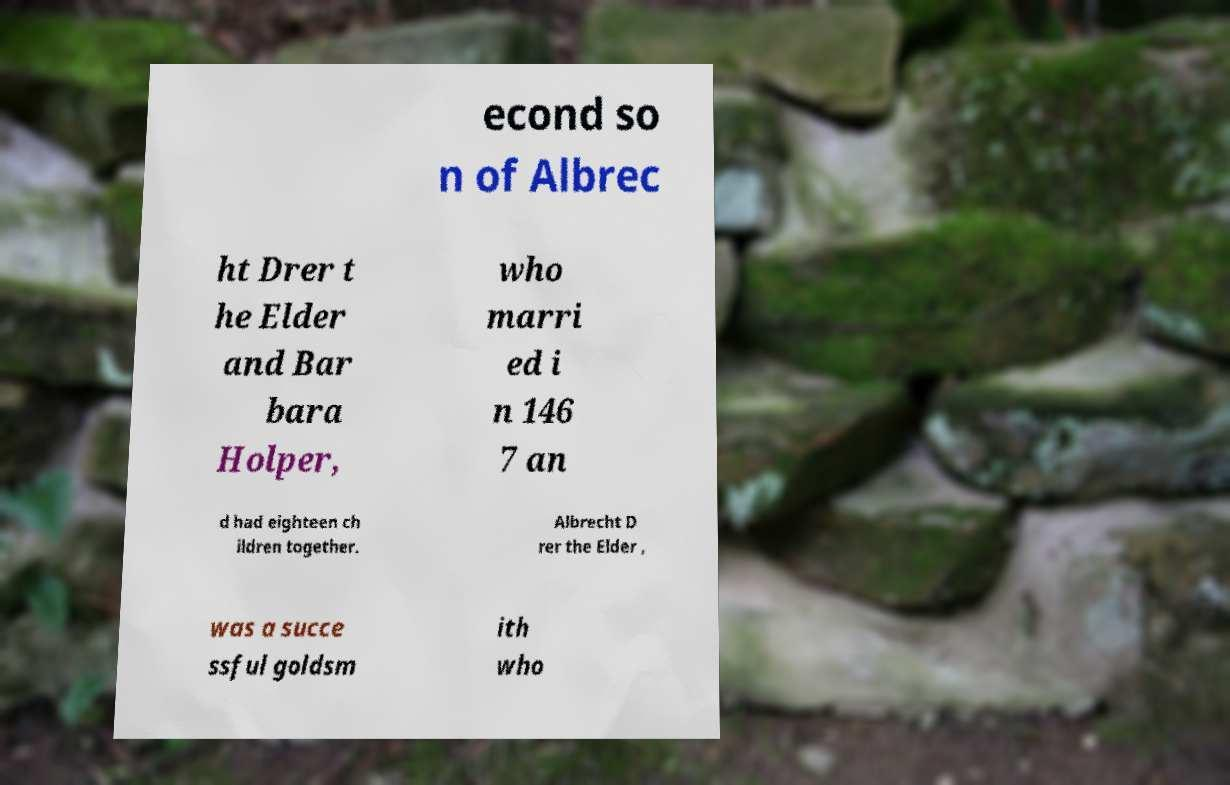For documentation purposes, I need the text within this image transcribed. Could you provide that? econd so n of Albrec ht Drer t he Elder and Bar bara Holper, who marri ed i n 146 7 an d had eighteen ch ildren together. Albrecht D rer the Elder , was a succe ssful goldsm ith who 